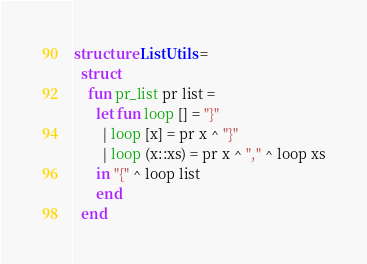<code> <loc_0><loc_0><loc_500><loc_500><_SML_>structure ListUtils =
  struct
    fun pr_list pr list =
      let fun loop [] = "}"
	    | loop [x] = pr x ^ "}"
	    | loop (x::xs) = pr x ^ "," ^ loop xs
      in "{" ^ loop list
      end
  end</code> 